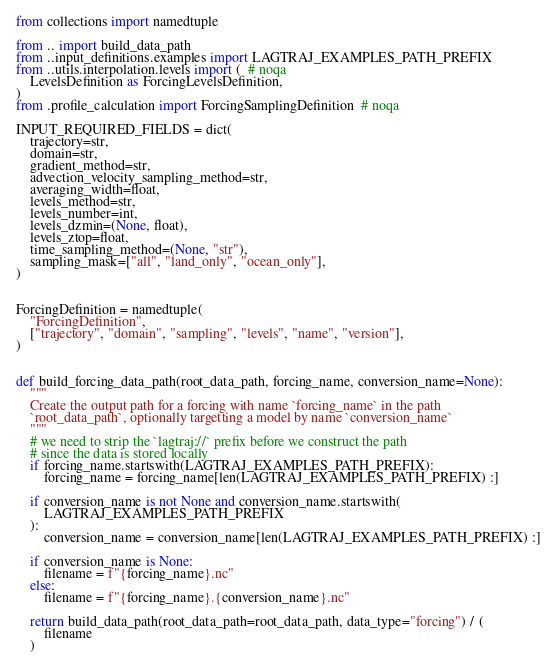Convert code to text. <code><loc_0><loc_0><loc_500><loc_500><_Python_>from collections import namedtuple

from .. import build_data_path
from ..input_definitions.examples import LAGTRAJ_EXAMPLES_PATH_PREFIX
from ..utils.interpolation.levels import (  # noqa
    LevelsDefinition as ForcingLevelsDefinition,
)
from .profile_calculation import ForcingSamplingDefinition  # noqa

INPUT_REQUIRED_FIELDS = dict(
    trajectory=str,
    domain=str,
    gradient_method=str,
    advection_velocity_sampling_method=str,
    averaging_width=float,
    levels_method=str,
    levels_number=int,
    levels_dzmin=(None, float),
    levels_ztop=float,
    time_sampling_method=(None, "str"),
    sampling_mask=["all", "land_only", "ocean_only"],
)


ForcingDefinition = namedtuple(
    "ForcingDefinition",
    ["trajectory", "domain", "sampling", "levels", "name", "version"],
)


def build_forcing_data_path(root_data_path, forcing_name, conversion_name=None):
    """
    Create the output path for a forcing with name `forcing_name` in the path
    `root_data_path`, optionally targetting a model by name `conversion_name`
    """
    # we need to strip the `lagtraj://` prefix before we construct the path
    # since the data is stored locally
    if forcing_name.startswith(LAGTRAJ_EXAMPLES_PATH_PREFIX):
        forcing_name = forcing_name[len(LAGTRAJ_EXAMPLES_PATH_PREFIX) :]

    if conversion_name is not None and conversion_name.startswith(
        LAGTRAJ_EXAMPLES_PATH_PREFIX
    ):
        conversion_name = conversion_name[len(LAGTRAJ_EXAMPLES_PATH_PREFIX) :]

    if conversion_name is None:
        filename = f"{forcing_name}.nc"
    else:
        filename = f"{forcing_name}.{conversion_name}.nc"

    return build_data_path(root_data_path=root_data_path, data_type="forcing") / (
        filename
    )
</code> 